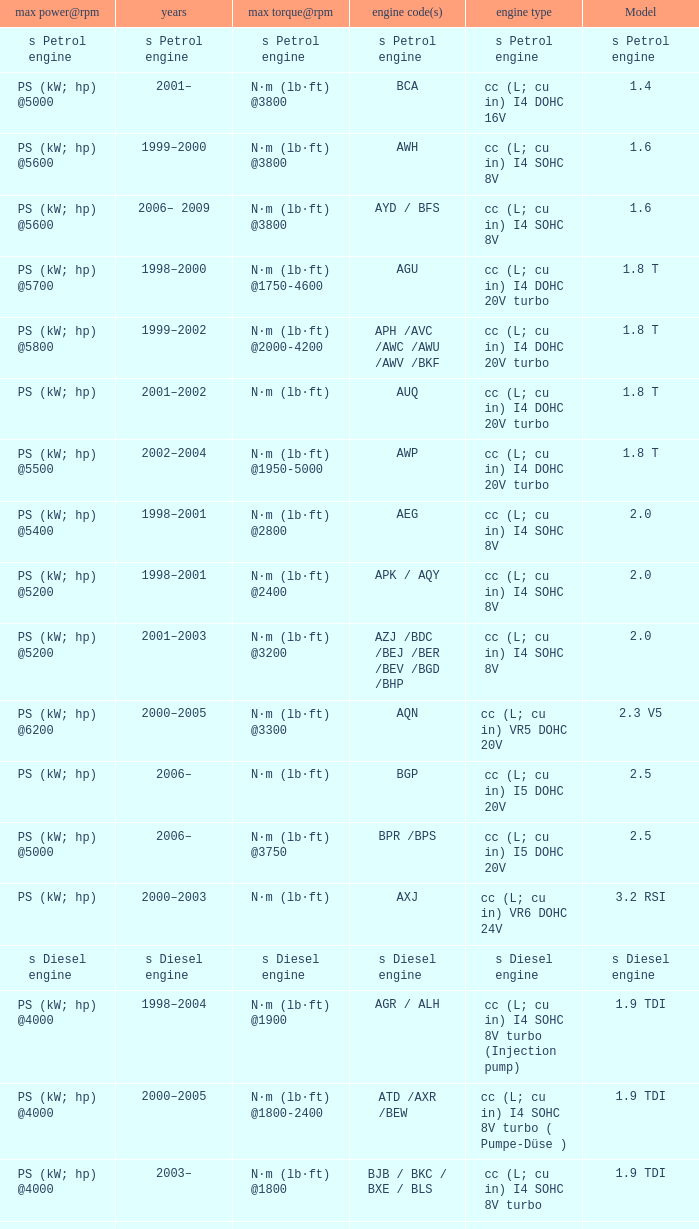Which engine type was used in the model 2.3 v5? Cc (l; cu in) vr5 dohc 20v. Can you give me this table as a dict? {'header': ['max power@rpm', 'years', 'max torque@rpm', 'engine code(s)', 'engine type', 'Model'], 'rows': [['s Petrol engine', 's Petrol engine', 's Petrol engine', 's Petrol engine', 's Petrol engine', 's Petrol engine'], ['PS (kW; hp) @5000', '2001–', 'N·m (lb·ft) @3800', 'BCA', 'cc (L; cu in) I4 DOHC 16V', '1.4'], ['PS (kW; hp) @5600', '1999–2000', 'N·m (lb·ft) @3800', 'AWH', 'cc (L; cu in) I4 SOHC 8V', '1.6'], ['PS (kW; hp) @5600', '2006– 2009', 'N·m (lb·ft) @3800', 'AYD / BFS', 'cc (L; cu in) I4 SOHC 8V', '1.6'], ['PS (kW; hp) @5700', '1998–2000', 'N·m (lb·ft) @1750-4600', 'AGU', 'cc (L; cu in) I4 DOHC 20V turbo', '1.8 T'], ['PS (kW; hp) @5800', '1999–2002', 'N·m (lb·ft) @2000-4200', 'APH /AVC /AWC /AWU /AWV /BKF', 'cc (L; cu in) I4 DOHC 20V turbo', '1.8 T'], ['PS (kW; hp)', '2001–2002', 'N·m (lb·ft)', 'AUQ', 'cc (L; cu in) I4 DOHC 20V turbo', '1.8 T'], ['PS (kW; hp) @5500', '2002–2004', 'N·m (lb·ft) @1950-5000', 'AWP', 'cc (L; cu in) I4 DOHC 20V turbo', '1.8 T'], ['PS (kW; hp) @5400', '1998–2001', 'N·m (lb·ft) @2800', 'AEG', 'cc (L; cu in) I4 SOHC 8V', '2.0'], ['PS (kW; hp) @5200', '1998–2001', 'N·m (lb·ft) @2400', 'APK / AQY', 'cc (L; cu in) I4 SOHC 8V', '2.0'], ['PS (kW; hp) @5200', '2001–2003', 'N·m (lb·ft) @3200', 'AZJ /BDC /BEJ /BER /BEV /BGD /BHP', 'cc (L; cu in) I4 SOHC 8V', '2.0'], ['PS (kW; hp) @6200', '2000–2005', 'N·m (lb·ft) @3300', 'AQN', 'cc (L; cu in) VR5 DOHC 20V', '2.3 V5'], ['PS (kW; hp)', '2006–', 'N·m (lb·ft)', 'BGP', 'cc (L; cu in) I5 DOHC 20V', '2.5'], ['PS (kW; hp) @5000', '2006–', 'N·m (lb·ft) @3750', 'BPR /BPS', 'cc (L; cu in) I5 DOHC 20V', '2.5'], ['PS (kW; hp)', '2000–2003', 'N·m (lb·ft)', 'AXJ', 'cc (L; cu in) VR6 DOHC 24V', '3.2 RSI'], ['s Diesel engine', 's Diesel engine', 's Diesel engine', 's Diesel engine', 's Diesel engine', 's Diesel engine'], ['PS (kW; hp) @4000', '1998–2004', 'N·m (lb·ft) @1900', 'AGR / ALH', 'cc (L; cu in) I4 SOHC 8V turbo (Injection pump)', '1.9 TDI'], ['PS (kW; hp) @4000', '2000–2005', 'N·m (lb·ft) @1800-2400', 'ATD /AXR /BEW', 'cc (L; cu in) I4 SOHC 8V turbo ( Pumpe-Düse )', '1.9 TDI'], ['PS (kW; hp) @4000', '2003–', 'N·m (lb·ft) @1800', 'BJB / BKC / BXE / BLS', 'cc (L; cu in) I4 SOHC 8V turbo', '1.9 TDI'], ['PS (kW; hp) @4000', '2005–2006', 'N·m (lb·ft) @1800-2200', 'BSW', 'cc (L; cu in) I4 SOHC 8V turbo ( Pumpe-Düse )', '1.9 TDI']]} 